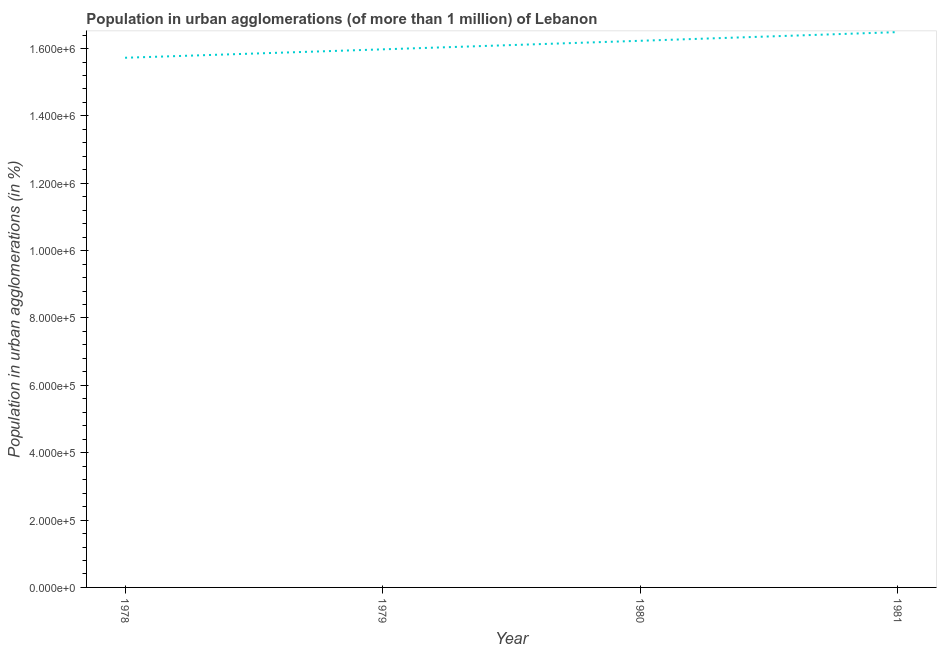What is the population in urban agglomerations in 1978?
Provide a succinct answer. 1.57e+06. Across all years, what is the maximum population in urban agglomerations?
Your response must be concise. 1.65e+06. Across all years, what is the minimum population in urban agglomerations?
Your response must be concise. 1.57e+06. In which year was the population in urban agglomerations maximum?
Your response must be concise. 1981. In which year was the population in urban agglomerations minimum?
Offer a terse response. 1978. What is the sum of the population in urban agglomerations?
Provide a short and direct response. 6.44e+06. What is the difference between the population in urban agglomerations in 1980 and 1981?
Offer a terse response. -2.58e+04. What is the average population in urban agglomerations per year?
Ensure brevity in your answer.  1.61e+06. What is the median population in urban agglomerations?
Your answer should be compact. 1.61e+06. In how many years, is the population in urban agglomerations greater than 640000 %?
Your answer should be compact. 4. Do a majority of the years between 1979 and 1978 (inclusive) have population in urban agglomerations greater than 680000 %?
Offer a terse response. No. What is the ratio of the population in urban agglomerations in 1978 to that in 1980?
Keep it short and to the point. 0.97. Is the difference between the population in urban agglomerations in 1978 and 1980 greater than the difference between any two years?
Offer a terse response. No. What is the difference between the highest and the second highest population in urban agglomerations?
Provide a short and direct response. 2.58e+04. Is the sum of the population in urban agglomerations in 1980 and 1981 greater than the maximum population in urban agglomerations across all years?
Provide a succinct answer. Yes. What is the difference between the highest and the lowest population in urban agglomerations?
Provide a succinct answer. 7.62e+04. Does the population in urban agglomerations monotonically increase over the years?
Offer a terse response. Yes. How many lines are there?
Your answer should be compact. 1. What is the difference between two consecutive major ticks on the Y-axis?
Make the answer very short. 2.00e+05. Does the graph contain any zero values?
Offer a very short reply. No. What is the title of the graph?
Offer a very short reply. Population in urban agglomerations (of more than 1 million) of Lebanon. What is the label or title of the X-axis?
Your answer should be compact. Year. What is the label or title of the Y-axis?
Offer a very short reply. Population in urban agglomerations (in %). What is the Population in urban agglomerations (in %) in 1978?
Provide a short and direct response. 1.57e+06. What is the Population in urban agglomerations (in %) in 1979?
Give a very brief answer. 1.60e+06. What is the Population in urban agglomerations (in %) of 1980?
Provide a succinct answer. 1.62e+06. What is the Population in urban agglomerations (in %) in 1981?
Provide a succinct answer. 1.65e+06. What is the difference between the Population in urban agglomerations (in %) in 1978 and 1979?
Make the answer very short. -2.50e+04. What is the difference between the Population in urban agglomerations (in %) in 1978 and 1980?
Your response must be concise. -5.04e+04. What is the difference between the Population in urban agglomerations (in %) in 1978 and 1981?
Your response must be concise. -7.62e+04. What is the difference between the Population in urban agglomerations (in %) in 1979 and 1980?
Offer a terse response. -2.54e+04. What is the difference between the Population in urban agglomerations (in %) in 1979 and 1981?
Give a very brief answer. -5.12e+04. What is the difference between the Population in urban agglomerations (in %) in 1980 and 1981?
Offer a very short reply. -2.58e+04. What is the ratio of the Population in urban agglomerations (in %) in 1978 to that in 1981?
Your answer should be very brief. 0.95. What is the ratio of the Population in urban agglomerations (in %) in 1979 to that in 1980?
Offer a terse response. 0.98. 